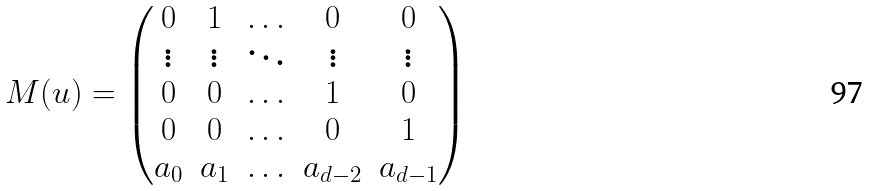<formula> <loc_0><loc_0><loc_500><loc_500>M ( u ) = \left ( \begin{matrix} 0 & 1 & \hdots & 0 & 0 \\ \vdots & \vdots & \ddots & \vdots & \vdots \\ 0 & 0 & \hdots & 1 & 0 \\ 0 & 0 & \hdots & 0 & 1 \\ a _ { 0 } & a _ { 1 } & \hdots & a _ { d - 2 } & a _ { d - 1 } \end{matrix} \right )</formula> 